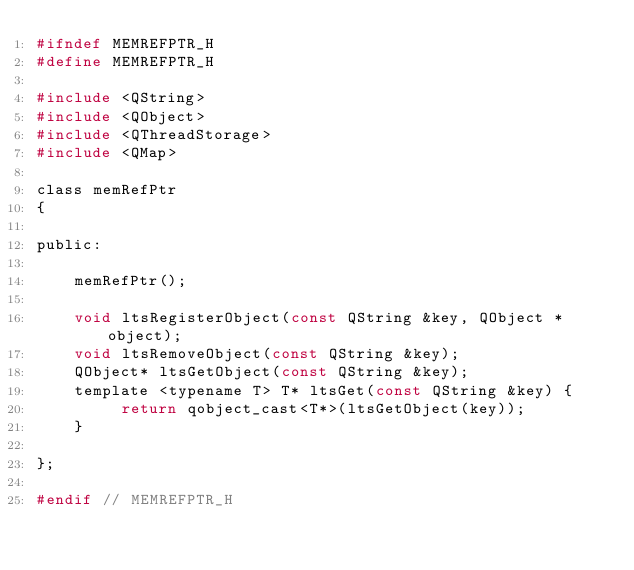Convert code to text. <code><loc_0><loc_0><loc_500><loc_500><_C_>#ifndef MEMREFPTR_H
#define MEMREFPTR_H

#include <QString>
#include <QObject>
#include <QThreadStorage>
#include <QMap>

class memRefPtr
{

public:

    memRefPtr();

    void ltsRegisterObject(const QString &key, QObject *object);
    void ltsRemoveObject(const QString &key);
    QObject* ltsGetObject(const QString &key);
    template <typename T> T* ltsGet(const QString &key) {
         return qobject_cast<T*>(ltsGetObject(key));
    }

};

#endif // MEMREFPTR_H
</code> 